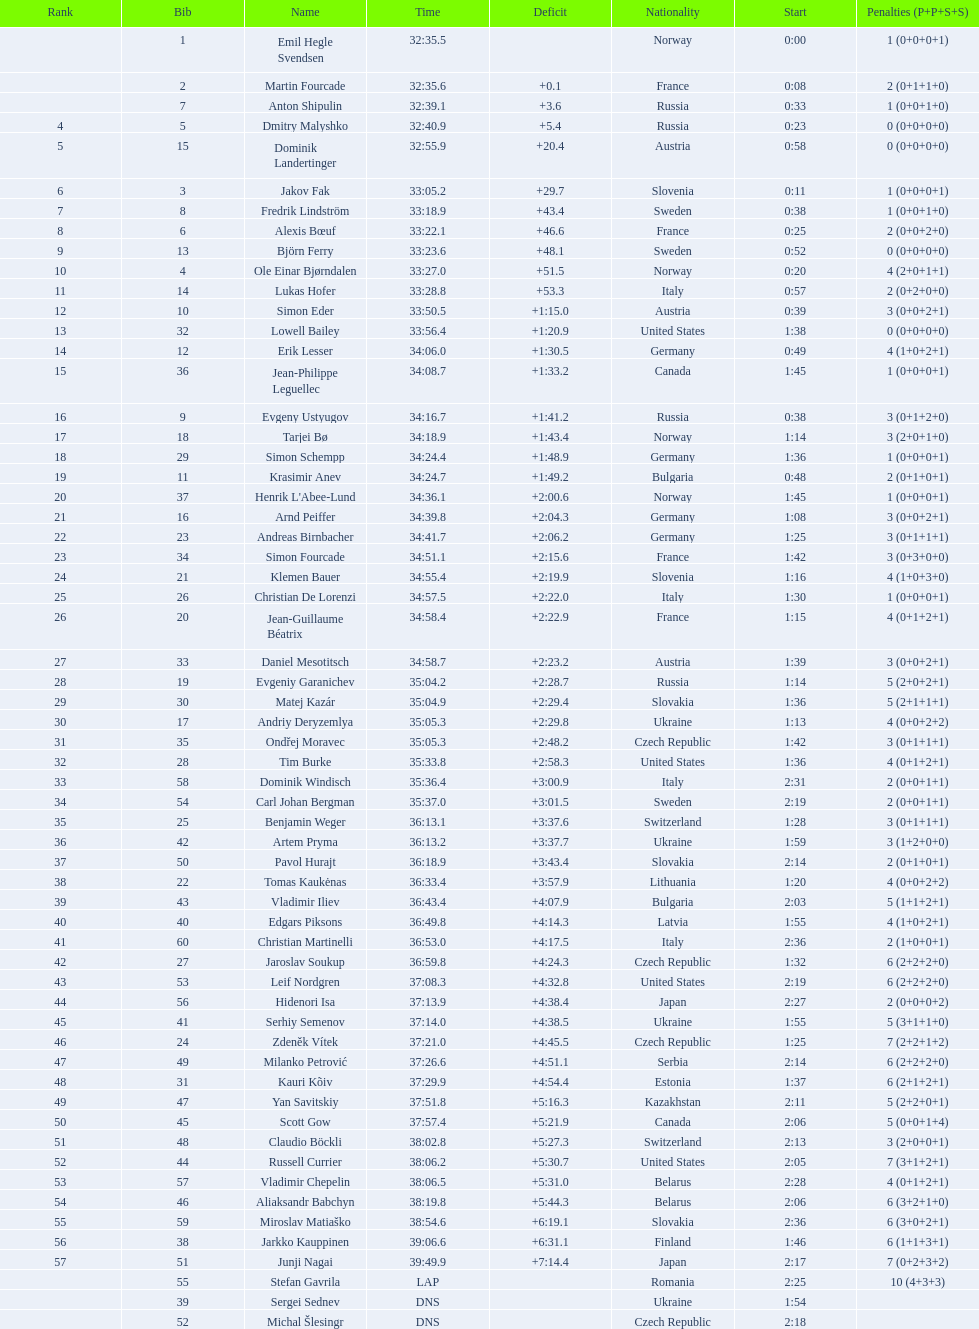What is the most severe penalty? 10. 